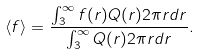Convert formula to latex. <formula><loc_0><loc_0><loc_500><loc_500>\langle f \rangle = \frac { \int _ { 3 } ^ { \infty } f ( r ) Q ( r ) 2 \pi r d r } { \int _ { 3 } ^ { \infty } Q ( r ) 2 \pi r d r } .</formula> 